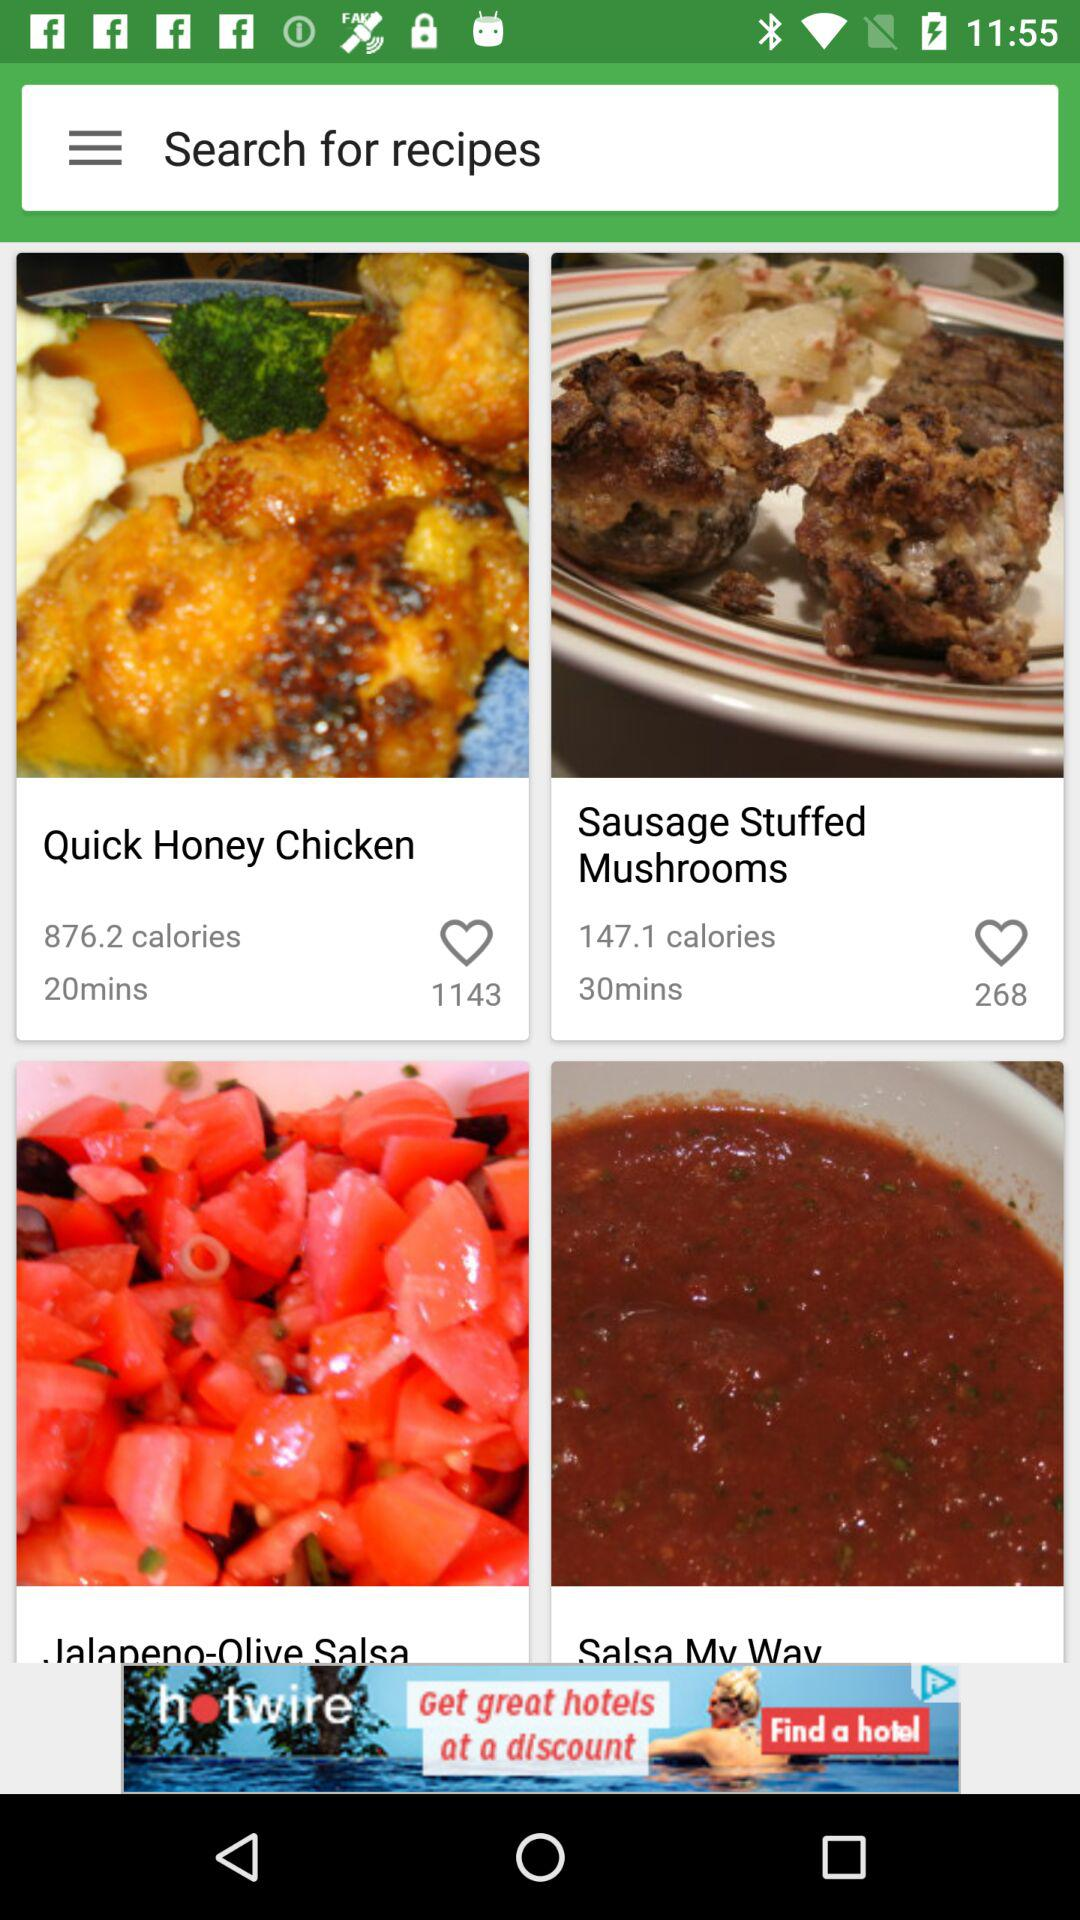How many calories are in "Quick Honey Chicken"? There are 876.2 calories in "Quick Honey Chicken". 